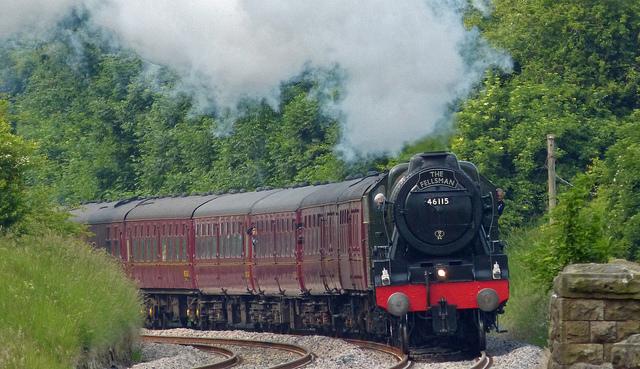Is it coming towards you or going away from you?
Keep it brief. Towards. Is this a full sized or miniature train?
Short answer required. Full sized. How many train tracks are there?
Answer briefly. 2. What are the numbers seen in the train?
Write a very short answer. 46115. Is this a passenger train?
Answer briefly. Yes. 